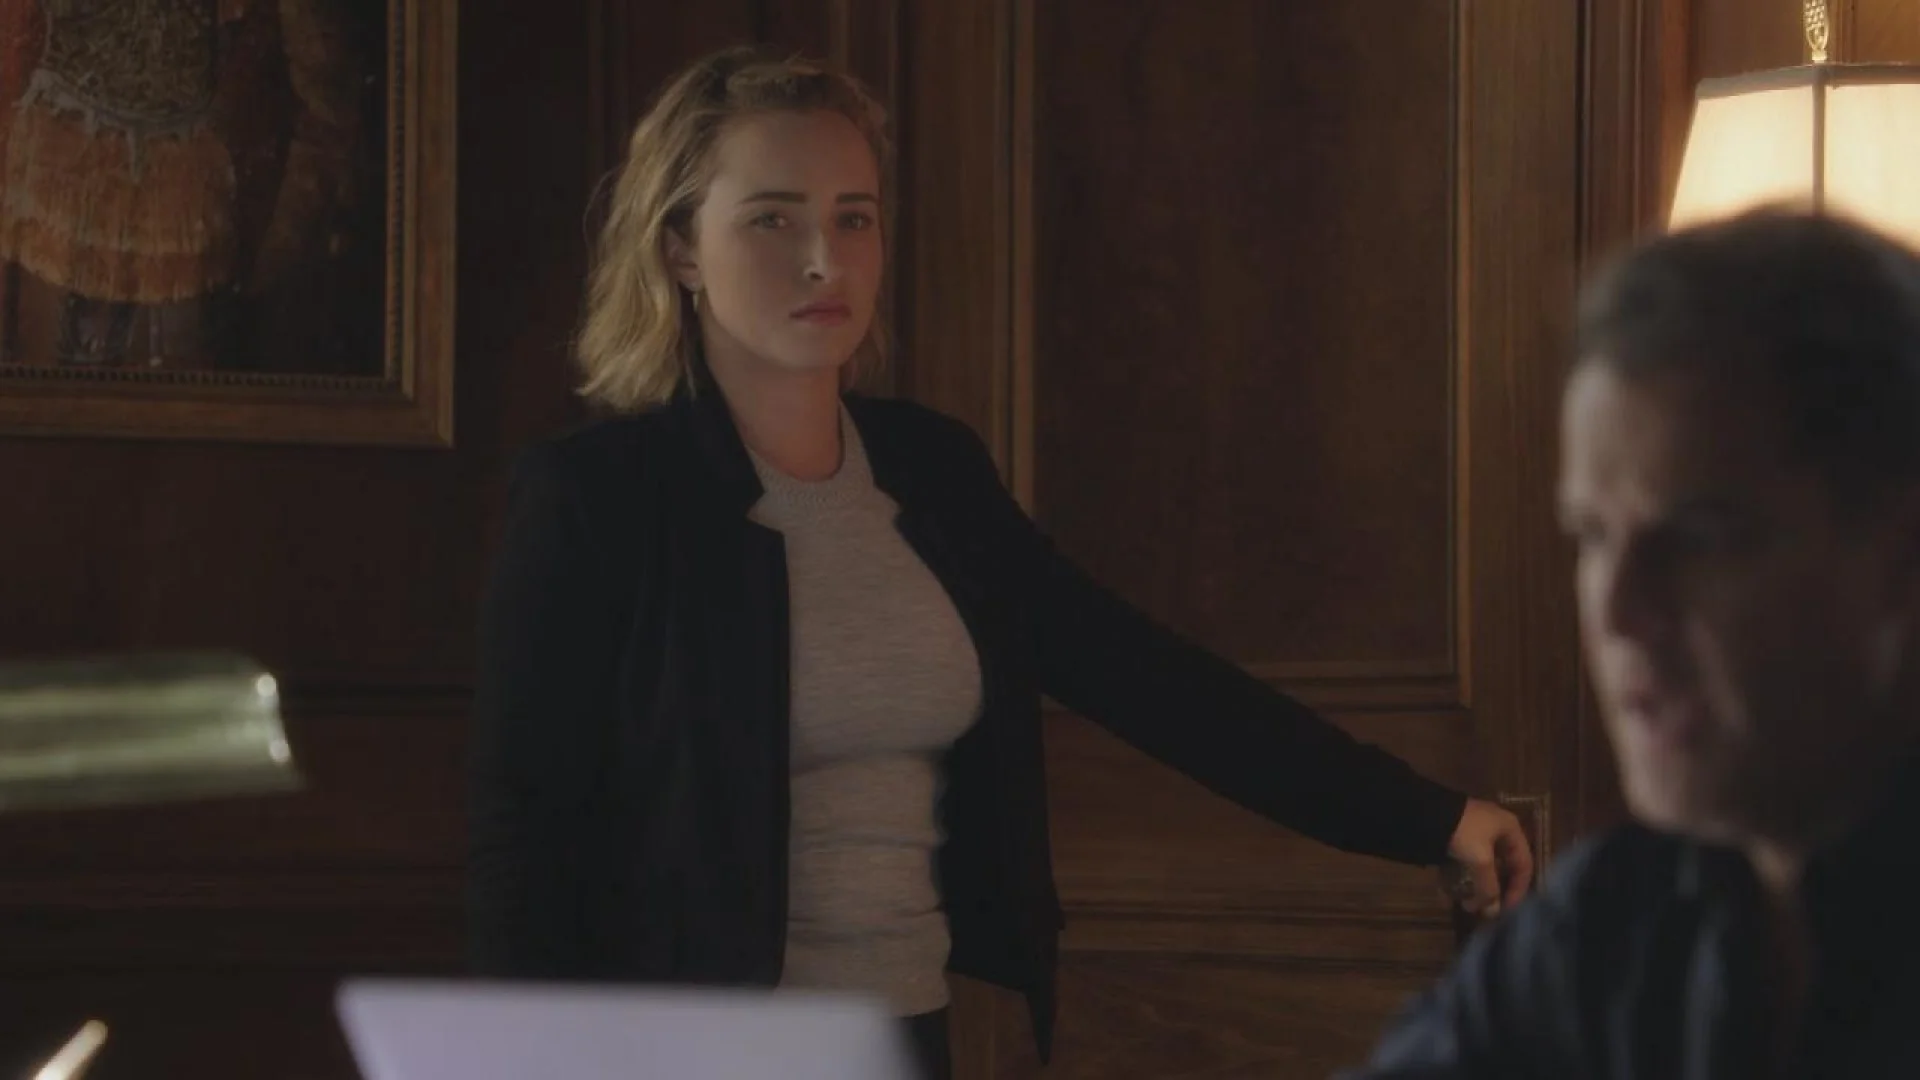What might be the topic of discussion between the two individuals? Given the intense expressions and the office-like environment, the discussion could likely revolve around important professional matters or critical business decisions. The woman's pointed gesture suggests she is making a strong point or addressing a serious issue. 